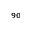<formula> <loc_0><loc_0><loc_500><loc_500>_ { 9 0 }</formula> 